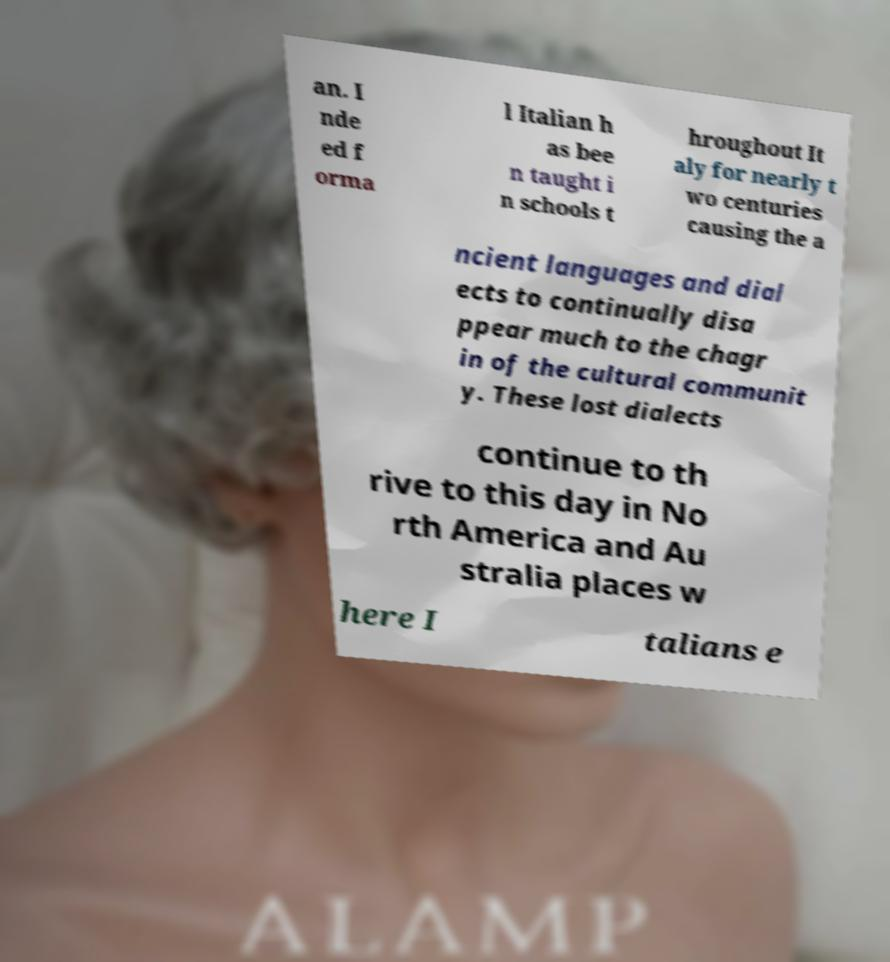Could you assist in decoding the text presented in this image and type it out clearly? an. I nde ed f orma l Italian h as bee n taught i n schools t hroughout It aly for nearly t wo centuries causing the a ncient languages and dial ects to continually disa ppear much to the chagr in of the cultural communit y. These lost dialects continue to th rive to this day in No rth America and Au stralia places w here I talians e 